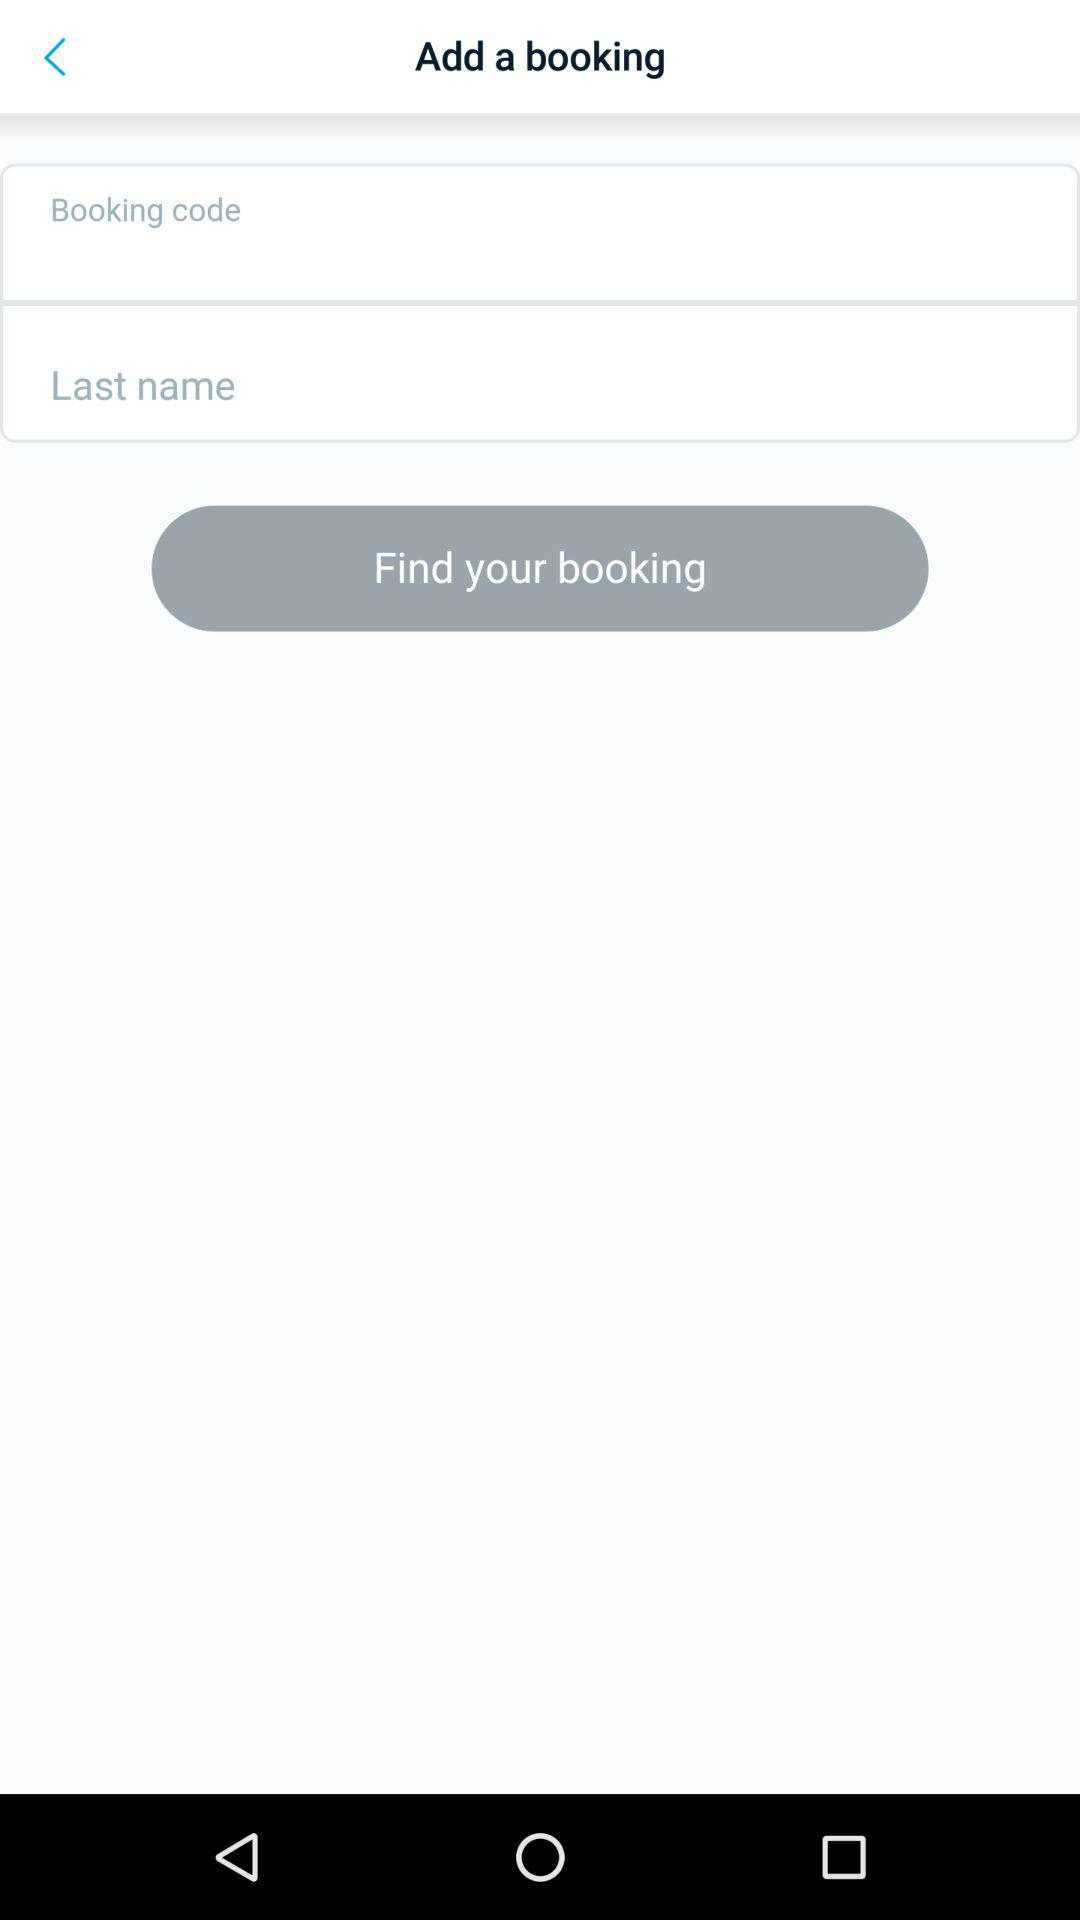How many input fields do I need to fill out to find my booking?
Answer the question using a single word or phrase. 2 